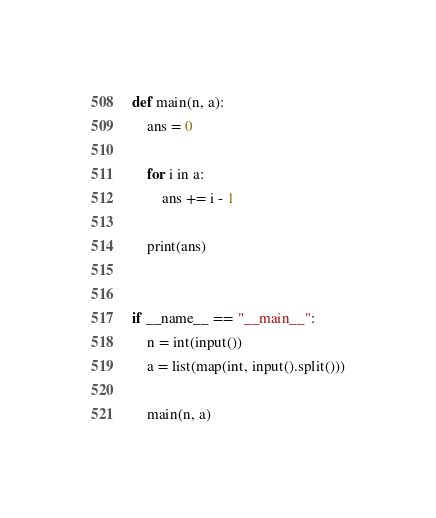Convert code to text. <code><loc_0><loc_0><loc_500><loc_500><_Python_>def main(n, a):
    ans = 0

    for i in a:
        ans += i - 1

    print(ans)


if __name__ == "__main__":
    n = int(input())
    a = list(map(int, input().split()))

    main(n, a)
</code> 